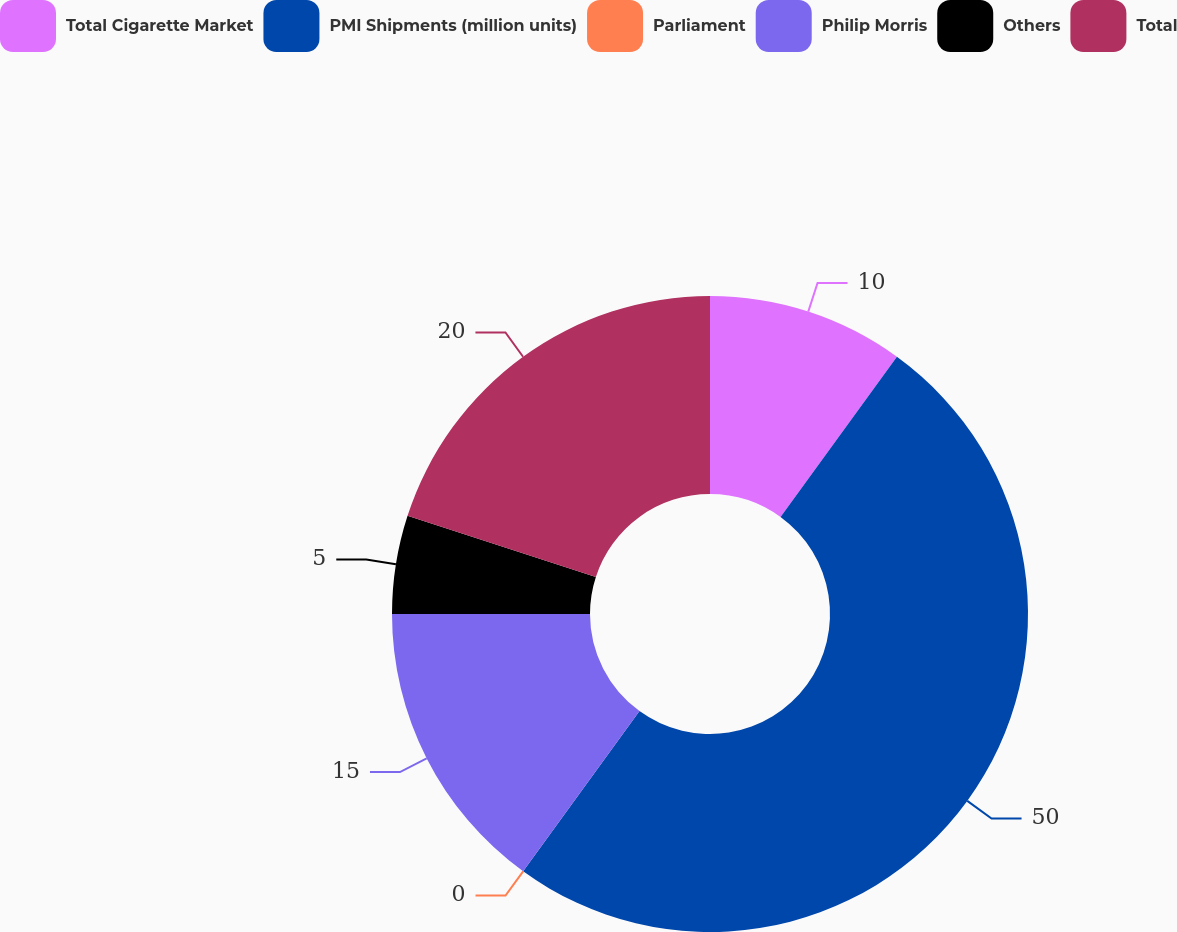<chart> <loc_0><loc_0><loc_500><loc_500><pie_chart><fcel>Total Cigarette Market<fcel>PMI Shipments (million units)<fcel>Parliament<fcel>Philip Morris<fcel>Others<fcel>Total<nl><fcel>10.0%<fcel>49.99%<fcel>0.0%<fcel>15.0%<fcel>5.0%<fcel>20.0%<nl></chart> 